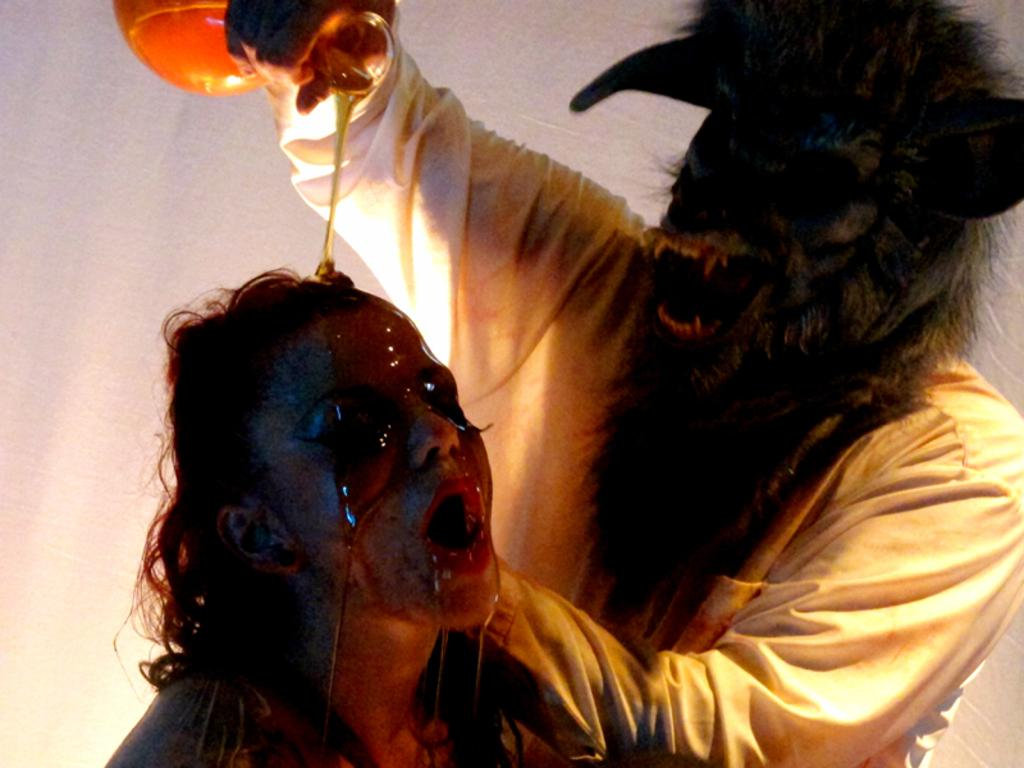How many people are present in the image? There are two people in the image. What are the people wearing? The two people are wearing fancy dresses. Can you describe the person holding an object in the image? Yes, there is a person holding an object in the image. What is the color of the background in the image? The background of the image is white. What type of flowers can be seen growing along the boundary in the image? There is no boundary or flowers present in the image; it features two people wearing fancy dresses with a white background. 